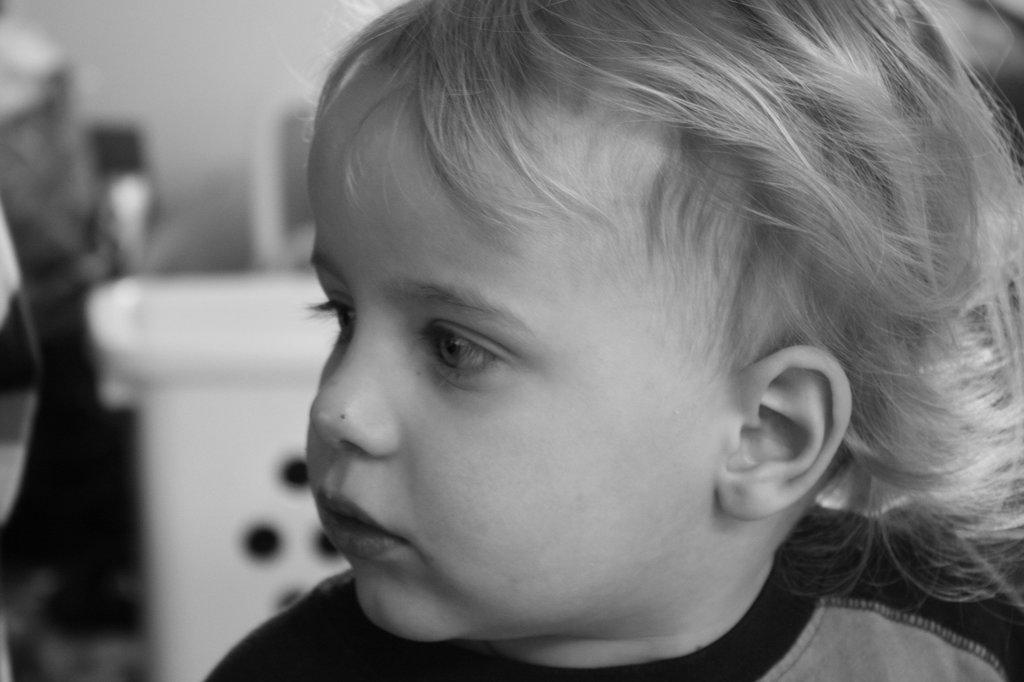How would you summarize this image in a sentence or two? A black and white picture. The kid is highlighted in this picture. 